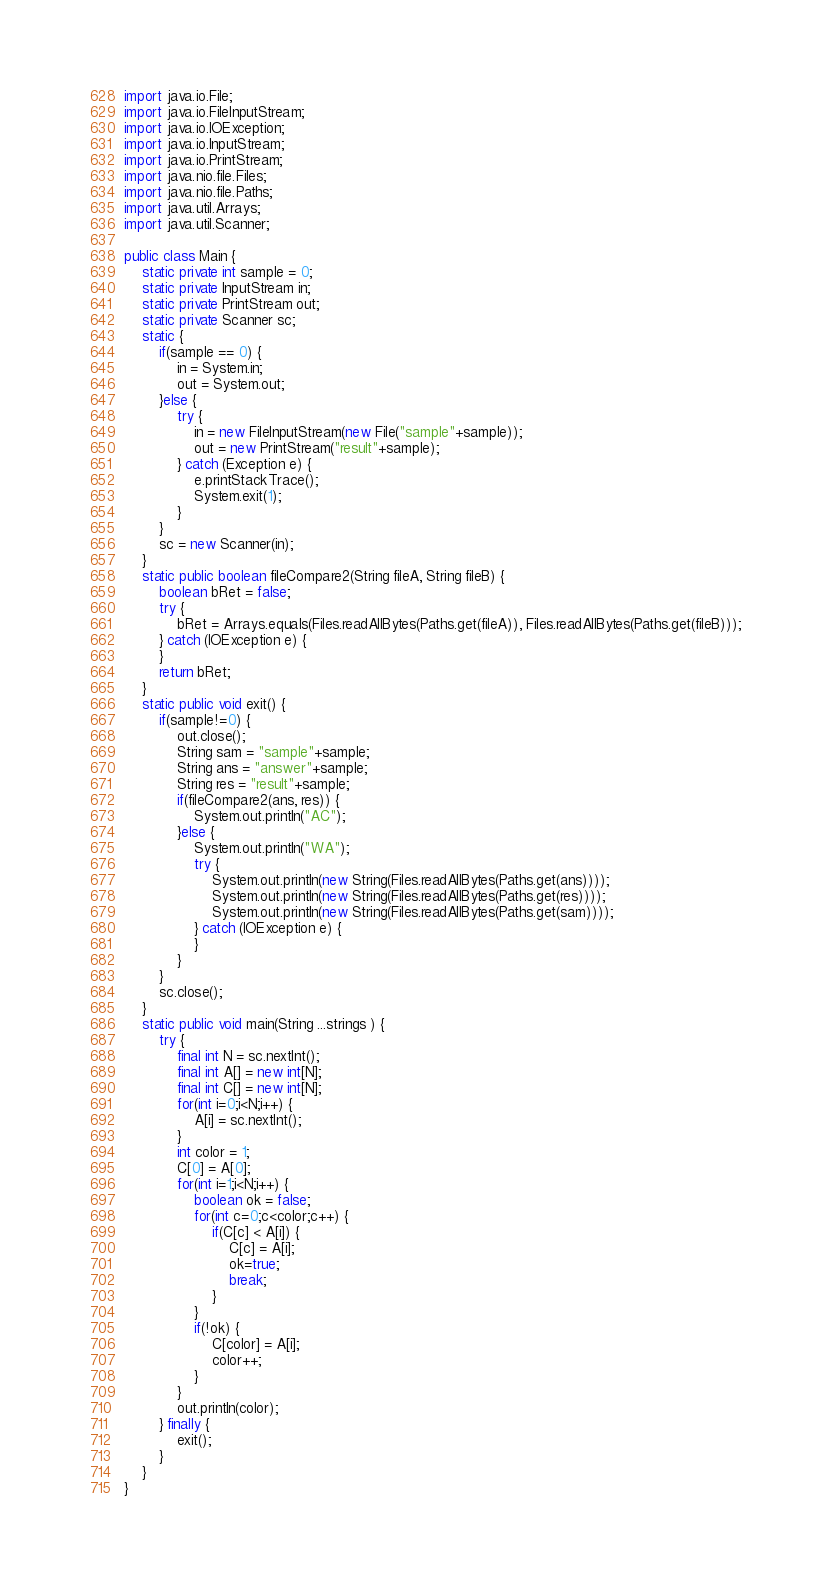<code> <loc_0><loc_0><loc_500><loc_500><_Java_>import java.io.File;
import java.io.FileInputStream;
import java.io.IOException;
import java.io.InputStream;
import java.io.PrintStream;
import java.nio.file.Files;
import java.nio.file.Paths;
import java.util.Arrays;
import java.util.Scanner;

public class Main {
	static private int sample = 0;
	static private InputStream in;
	static private PrintStream out;
	static private Scanner sc;
	static {
		if(sample == 0) {
			in = System.in;
			out = System.out;
		}else {
			try {
				in = new FileInputStream(new File("sample"+sample));
				out = new PrintStream("result"+sample);
			} catch (Exception e) {
				e.printStackTrace();
				System.exit(1);
			}
		}
		sc = new Scanner(in);
	}
	static public boolean fileCompare2(String fileA, String fileB) {
		boolean bRet = false;
		try {
			bRet = Arrays.equals(Files.readAllBytes(Paths.get(fileA)), Files.readAllBytes(Paths.get(fileB)));
		} catch (IOException e) {
		}
		return bRet;
	}
	static public void exit() {
		if(sample!=0) {
			out.close();
			String sam = "sample"+sample;
			String ans = "answer"+sample;
			String res = "result"+sample;
			if(fileCompare2(ans, res)) {
				System.out.println("AC");
			}else {
				System.out.println("WA");
				try {
					System.out.println(new String(Files.readAllBytes(Paths.get(ans))));
					System.out.println(new String(Files.readAllBytes(Paths.get(res))));
					System.out.println(new String(Files.readAllBytes(Paths.get(sam))));
				} catch (IOException e) {
				}
			}
		}
		sc.close();
	}
	static public void main(String ...strings ) {
		try {
			final int N = sc.nextInt();
			final int A[] = new int[N];
			final int C[] = new int[N];
			for(int i=0;i<N;i++) {
				A[i] = sc.nextInt();
			}
			int color = 1;
			C[0] = A[0];
			for(int i=1;i<N;i++) {
				boolean ok = false;
				for(int c=0;c<color;c++) {
					if(C[c] < A[i]) {
						C[c] = A[i];
						ok=true;
						break;
					}
				}
				if(!ok) {
					C[color] = A[i];
					color++;
				}
			}
			out.println(color);
		} finally {
			exit();
		}
	}
}
</code> 